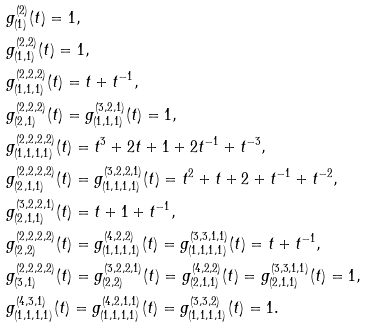Convert formula to latex. <formula><loc_0><loc_0><loc_500><loc_500>& g _ { ( 1 ) } ^ { ( 2 ) } ( t ) = 1 , \\ & g _ { ( 1 , 1 ) } ^ { ( 2 , 2 ) } ( t ) = 1 , \\ & g _ { ( 1 , 1 , 1 ) } ^ { ( 2 , 2 , 2 ) } ( t ) = t + t ^ { - 1 } , \\ & g _ { ( 2 , 1 ) } ^ { ( 2 , 2 , 2 ) } ( t ) = g _ { ( 1 , 1 , 1 ) } ^ { ( 3 , 2 , 1 ) } ( t ) = 1 , \\ & g _ { ( 1 , 1 , 1 , 1 ) } ^ { ( 2 , 2 , 2 , 2 ) } ( t ) = t ^ { 3 } + 2 t + 1 + 2 t ^ { - 1 } + t ^ { - 3 } , \\ & g _ { ( 2 , 1 , 1 ) } ^ { ( 2 , 2 , 2 , 2 ) } ( t ) = g _ { ( 1 , 1 , 1 , 1 ) } ^ { ( 3 , 2 , 2 , 1 ) } ( t ) = t ^ { 2 } + t + 2 + t ^ { - 1 } + t ^ { - 2 } , \\ & g _ { ( 2 , 1 , 1 ) } ^ { ( 3 , 2 , 2 , 1 ) } ( t ) = t + 1 + t ^ { - 1 } , \\ & g _ { ( 2 , 2 ) } ^ { ( 2 , 2 , 2 , 2 ) } ( t ) = g _ { ( 1 , 1 , 1 , 1 ) } ^ { ( 4 , 2 , 2 ) } ( t ) = g _ { ( 1 , 1 , 1 , 1 ) } ^ { ( 3 , 3 , 1 , 1 ) } ( t ) = t + t ^ { - 1 } , \\ & g _ { ( 3 , 1 ) } ^ { ( 2 , 2 , 2 , 2 ) } ( t ) = g _ { ( 2 , 2 ) } ^ { ( 3 , 2 , 2 , 1 ) } ( t ) = g _ { ( 2 , 1 , 1 ) } ^ { ( 4 , 2 , 2 ) } ( t ) = g _ { ( 2 , 1 , 1 ) } ^ { ( 3 , 3 , 1 , 1 ) } ( t ) = 1 , \\ & g _ { ( 1 , 1 , 1 , 1 ) } ^ { ( 4 , 3 , 1 ) } ( t ) = g _ { ( 1 , 1 , 1 , 1 ) } ^ { ( 4 , 2 , 1 , 1 ) } ( t ) = g _ { ( 1 , 1 , 1 , 1 ) } ^ { ( 3 , 3 , 2 ) } ( t ) = 1 .</formula> 